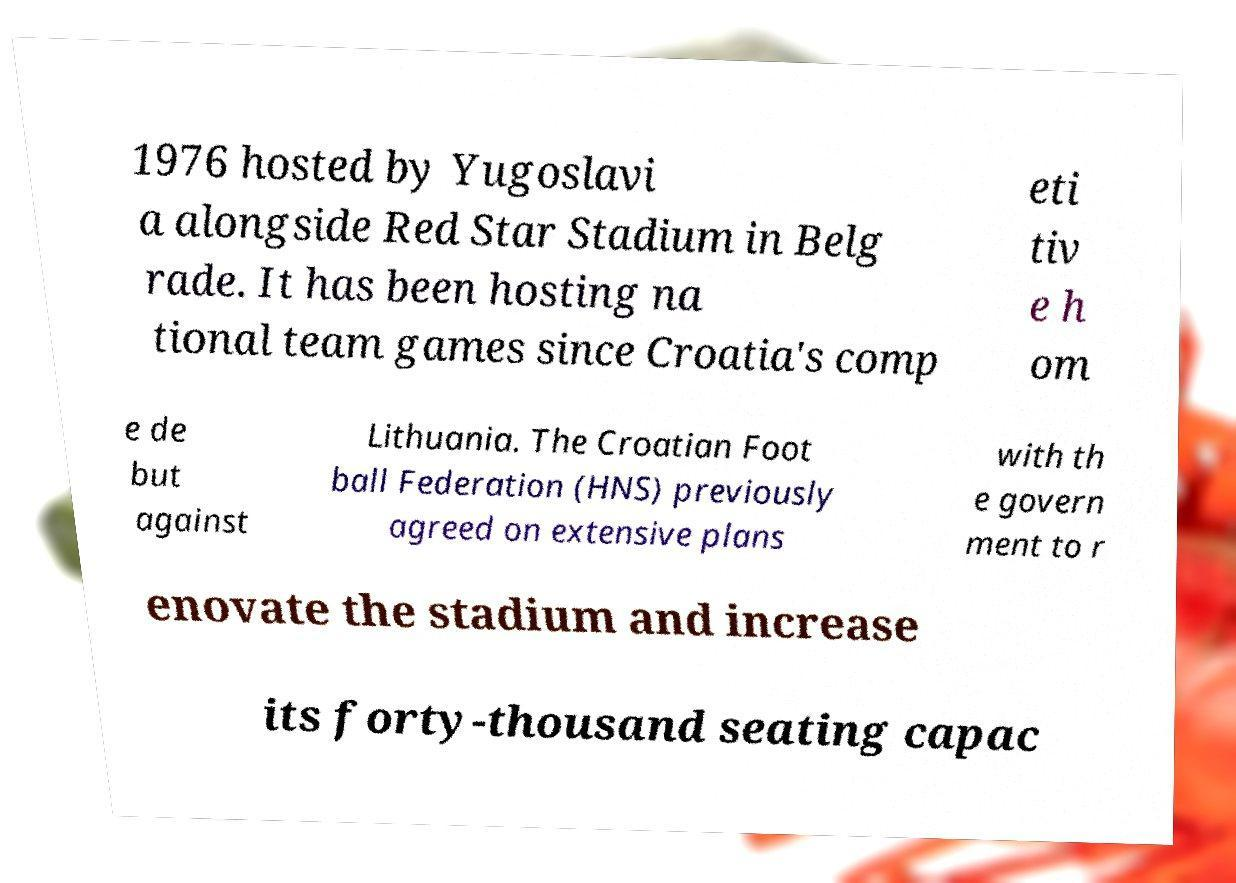Can you read and provide the text displayed in the image?This photo seems to have some interesting text. Can you extract and type it out for me? 1976 hosted by Yugoslavi a alongside Red Star Stadium in Belg rade. It has been hosting na tional team games since Croatia's comp eti tiv e h om e de but against Lithuania. The Croatian Foot ball Federation (HNS) previously agreed on extensive plans with th e govern ment to r enovate the stadium and increase its forty-thousand seating capac 